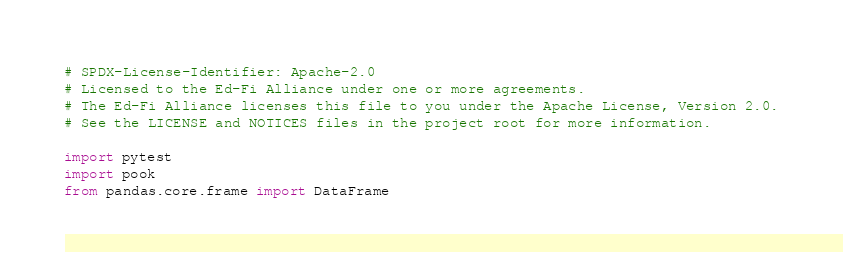Convert code to text. <code><loc_0><loc_0><loc_500><loc_500><_Python_># SPDX-License-Identifier: Apache-2.0
# Licensed to the Ed-Fi Alliance under one or more agreements.
# The Ed-Fi Alliance licenses this file to you under the Apache License, Version 2.0.
# See the LICENSE and NOTICES files in the project root for more information.

import pytest
import pook
from pandas.core.frame import DataFrame</code> 